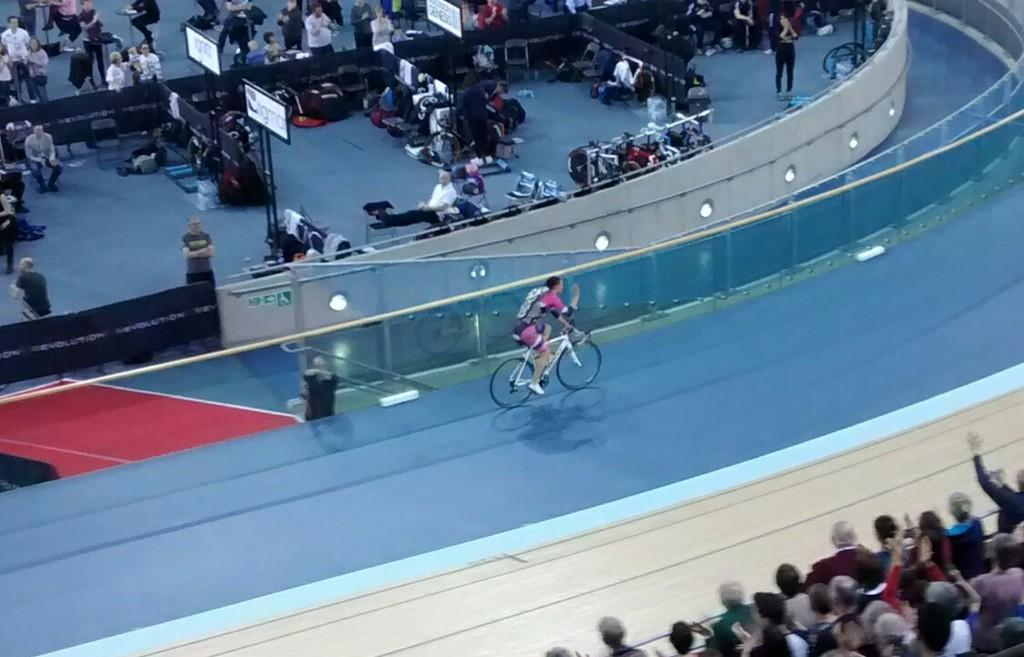What is the main subject of the image? There is a person riding a bicycle in the image. Where is the person riding the bicycle? The person is riding on the ground. What can be seen in the background of the image? There are fences in the image. Can you describe the group of people in the image? There is a group of people in the image, with some standing and some sitting. What else is present in the image besides the person on the bicycle and the group of people? There are objects in the image. Reasoning: Let' Let's think step by step in order to produce the conversation. We start by identifying the main subject of the image, which is the person riding a bicycle. Then, we describe the setting and context of the image, including the ground and the presence of fences. Next, we focus on the group of people, noting their positions and actions. Finally, we acknowledge the presence of other objects in the image, without specifying what they are. Absurd Question/Answer: What type of wire can be seen connecting the elbow of the person riding the bicycle to the downtown area? There is no wire connecting the elbow of the person riding the bicycle to the downtown area in the image. 